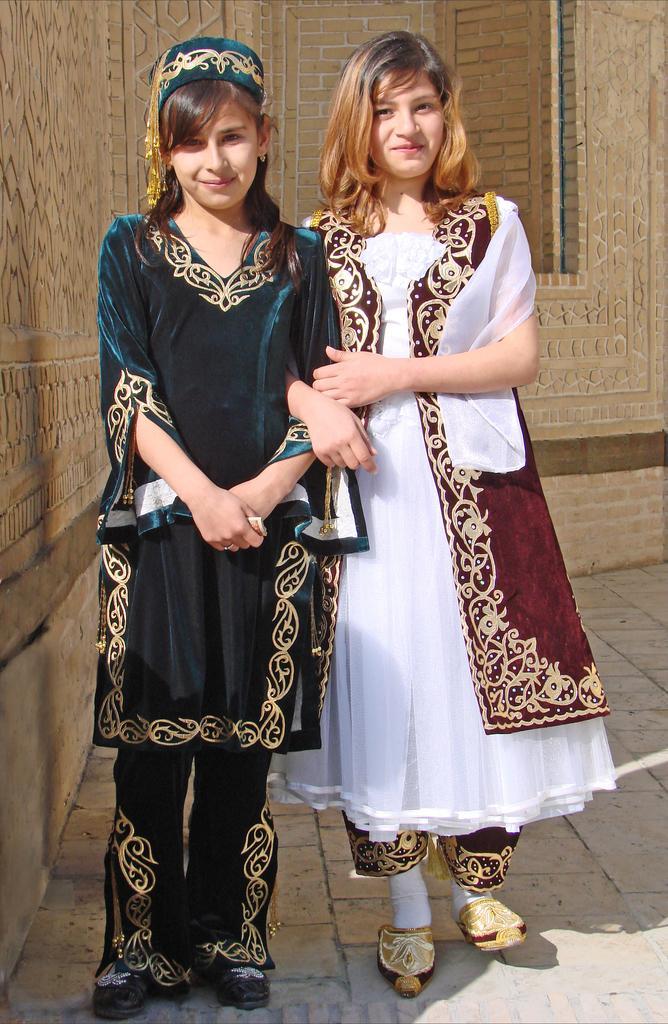Can you describe this image briefly? In this image I can see two persons standing. The person at right is wearing white and brown color dress and the person at left is wearing green color dress. In the background I can see the building in cream color. 